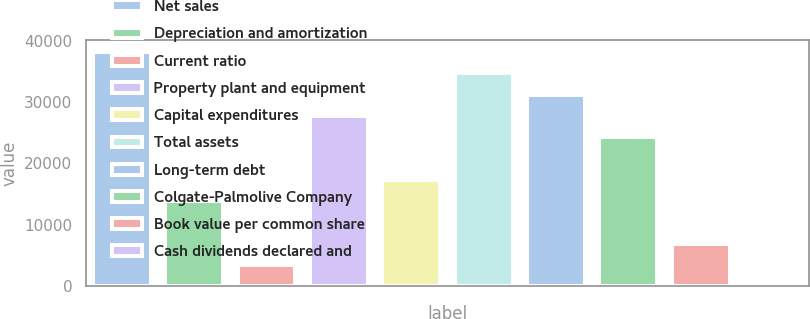Convert chart. <chart><loc_0><loc_0><loc_500><loc_500><bar_chart><fcel>Net sales<fcel>Depreciation and amortization<fcel>Current ratio<fcel>Property plant and equipment<fcel>Capital expenditures<fcel>Total assets<fcel>Long-term debt<fcel>Colgate-Palmolive Company<fcel>Book value per common share<fcel>Cash dividends declared and<nl><fcel>38170<fcel>13880.4<fcel>3470.57<fcel>27760.2<fcel>17350.3<fcel>34700<fcel>31230.1<fcel>24290.2<fcel>6940.51<fcel>0.63<nl></chart> 